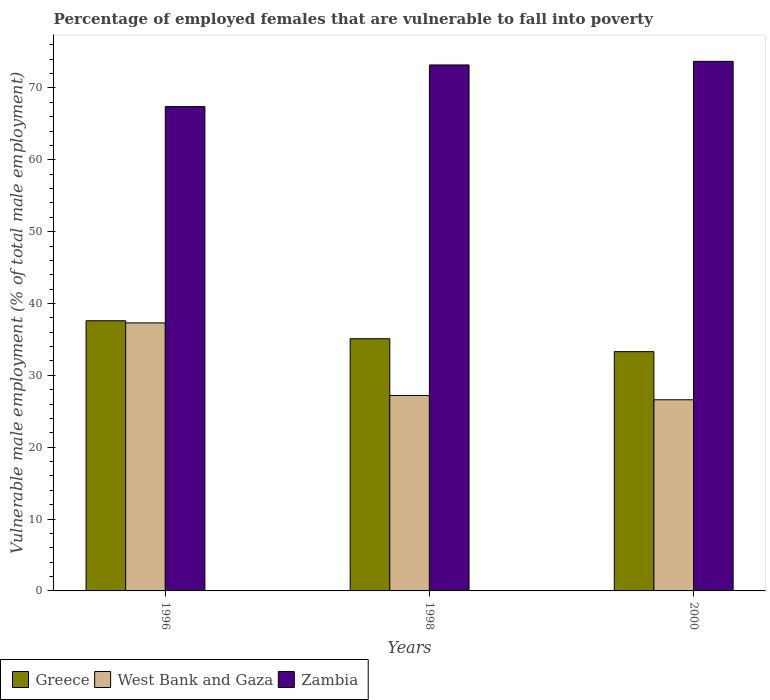How many groups of bars are there?
Your answer should be very brief. 3. Are the number of bars on each tick of the X-axis equal?
Ensure brevity in your answer.  Yes. How many bars are there on the 2nd tick from the right?
Your response must be concise. 3. In how many cases, is the number of bars for a given year not equal to the number of legend labels?
Offer a very short reply. 0. What is the percentage of employed females who are vulnerable to fall into poverty in West Bank and Gaza in 1996?
Keep it short and to the point. 37.3. Across all years, what is the maximum percentage of employed females who are vulnerable to fall into poverty in West Bank and Gaza?
Ensure brevity in your answer.  37.3. Across all years, what is the minimum percentage of employed females who are vulnerable to fall into poverty in Greece?
Offer a very short reply. 33.3. In which year was the percentage of employed females who are vulnerable to fall into poverty in West Bank and Gaza minimum?
Give a very brief answer. 2000. What is the total percentage of employed females who are vulnerable to fall into poverty in Greece in the graph?
Your answer should be compact. 106. What is the difference between the percentage of employed females who are vulnerable to fall into poverty in West Bank and Gaza in 1996 and that in 1998?
Provide a short and direct response. 10.1. What is the difference between the percentage of employed females who are vulnerable to fall into poverty in Zambia in 2000 and the percentage of employed females who are vulnerable to fall into poverty in Greece in 1998?
Provide a succinct answer. 38.6. What is the average percentage of employed females who are vulnerable to fall into poverty in West Bank and Gaza per year?
Offer a very short reply. 30.37. In the year 1996, what is the difference between the percentage of employed females who are vulnerable to fall into poverty in Greece and percentage of employed females who are vulnerable to fall into poverty in West Bank and Gaza?
Keep it short and to the point. 0.3. What is the ratio of the percentage of employed females who are vulnerable to fall into poverty in Zambia in 1998 to that in 2000?
Make the answer very short. 0.99. Is the difference between the percentage of employed females who are vulnerable to fall into poverty in Greece in 1998 and 2000 greater than the difference between the percentage of employed females who are vulnerable to fall into poverty in West Bank and Gaza in 1998 and 2000?
Make the answer very short. Yes. What is the difference between the highest and the second highest percentage of employed females who are vulnerable to fall into poverty in Zambia?
Your answer should be compact. 0.5. What is the difference between the highest and the lowest percentage of employed females who are vulnerable to fall into poverty in Zambia?
Offer a very short reply. 6.3. In how many years, is the percentage of employed females who are vulnerable to fall into poverty in Zambia greater than the average percentage of employed females who are vulnerable to fall into poverty in Zambia taken over all years?
Your answer should be very brief. 2. What does the 1st bar from the left in 2000 represents?
Keep it short and to the point. Greece. What does the 2nd bar from the right in 1996 represents?
Keep it short and to the point. West Bank and Gaza. How many bars are there?
Ensure brevity in your answer.  9. How many years are there in the graph?
Offer a very short reply. 3. What is the difference between two consecutive major ticks on the Y-axis?
Your response must be concise. 10. Does the graph contain grids?
Provide a succinct answer. No. How are the legend labels stacked?
Give a very brief answer. Horizontal. What is the title of the graph?
Your response must be concise. Percentage of employed females that are vulnerable to fall into poverty. What is the label or title of the Y-axis?
Your answer should be very brief. Vulnerable male employment (% of total male employment). What is the Vulnerable male employment (% of total male employment) in Greece in 1996?
Offer a terse response. 37.6. What is the Vulnerable male employment (% of total male employment) of West Bank and Gaza in 1996?
Your answer should be very brief. 37.3. What is the Vulnerable male employment (% of total male employment) of Zambia in 1996?
Your response must be concise. 67.4. What is the Vulnerable male employment (% of total male employment) of Greece in 1998?
Offer a very short reply. 35.1. What is the Vulnerable male employment (% of total male employment) in West Bank and Gaza in 1998?
Your response must be concise. 27.2. What is the Vulnerable male employment (% of total male employment) in Zambia in 1998?
Keep it short and to the point. 73.2. What is the Vulnerable male employment (% of total male employment) in Greece in 2000?
Keep it short and to the point. 33.3. What is the Vulnerable male employment (% of total male employment) in West Bank and Gaza in 2000?
Your answer should be compact. 26.6. What is the Vulnerable male employment (% of total male employment) in Zambia in 2000?
Offer a very short reply. 73.7. Across all years, what is the maximum Vulnerable male employment (% of total male employment) in Greece?
Offer a terse response. 37.6. Across all years, what is the maximum Vulnerable male employment (% of total male employment) in West Bank and Gaza?
Offer a very short reply. 37.3. Across all years, what is the maximum Vulnerable male employment (% of total male employment) of Zambia?
Your answer should be compact. 73.7. Across all years, what is the minimum Vulnerable male employment (% of total male employment) in Greece?
Your response must be concise. 33.3. Across all years, what is the minimum Vulnerable male employment (% of total male employment) in West Bank and Gaza?
Keep it short and to the point. 26.6. Across all years, what is the minimum Vulnerable male employment (% of total male employment) of Zambia?
Ensure brevity in your answer.  67.4. What is the total Vulnerable male employment (% of total male employment) in Greece in the graph?
Make the answer very short. 106. What is the total Vulnerable male employment (% of total male employment) in West Bank and Gaza in the graph?
Your answer should be very brief. 91.1. What is the total Vulnerable male employment (% of total male employment) of Zambia in the graph?
Make the answer very short. 214.3. What is the difference between the Vulnerable male employment (% of total male employment) of West Bank and Gaza in 1996 and that in 1998?
Ensure brevity in your answer.  10.1. What is the difference between the Vulnerable male employment (% of total male employment) of Zambia in 1996 and that in 1998?
Provide a succinct answer. -5.8. What is the difference between the Vulnerable male employment (% of total male employment) in Greece in 1996 and that in 2000?
Make the answer very short. 4.3. What is the difference between the Vulnerable male employment (% of total male employment) of West Bank and Gaza in 1996 and that in 2000?
Give a very brief answer. 10.7. What is the difference between the Vulnerable male employment (% of total male employment) of Greece in 1998 and that in 2000?
Provide a short and direct response. 1.8. What is the difference between the Vulnerable male employment (% of total male employment) of West Bank and Gaza in 1998 and that in 2000?
Your answer should be compact. 0.6. What is the difference between the Vulnerable male employment (% of total male employment) of Greece in 1996 and the Vulnerable male employment (% of total male employment) of Zambia in 1998?
Your answer should be compact. -35.6. What is the difference between the Vulnerable male employment (% of total male employment) of West Bank and Gaza in 1996 and the Vulnerable male employment (% of total male employment) of Zambia in 1998?
Your answer should be very brief. -35.9. What is the difference between the Vulnerable male employment (% of total male employment) in Greece in 1996 and the Vulnerable male employment (% of total male employment) in Zambia in 2000?
Make the answer very short. -36.1. What is the difference between the Vulnerable male employment (% of total male employment) in West Bank and Gaza in 1996 and the Vulnerable male employment (% of total male employment) in Zambia in 2000?
Make the answer very short. -36.4. What is the difference between the Vulnerable male employment (% of total male employment) of Greece in 1998 and the Vulnerable male employment (% of total male employment) of Zambia in 2000?
Offer a terse response. -38.6. What is the difference between the Vulnerable male employment (% of total male employment) in West Bank and Gaza in 1998 and the Vulnerable male employment (% of total male employment) in Zambia in 2000?
Ensure brevity in your answer.  -46.5. What is the average Vulnerable male employment (% of total male employment) in Greece per year?
Make the answer very short. 35.33. What is the average Vulnerable male employment (% of total male employment) in West Bank and Gaza per year?
Provide a succinct answer. 30.37. What is the average Vulnerable male employment (% of total male employment) in Zambia per year?
Your answer should be very brief. 71.43. In the year 1996, what is the difference between the Vulnerable male employment (% of total male employment) of Greece and Vulnerable male employment (% of total male employment) of West Bank and Gaza?
Offer a very short reply. 0.3. In the year 1996, what is the difference between the Vulnerable male employment (% of total male employment) in Greece and Vulnerable male employment (% of total male employment) in Zambia?
Provide a succinct answer. -29.8. In the year 1996, what is the difference between the Vulnerable male employment (% of total male employment) in West Bank and Gaza and Vulnerable male employment (% of total male employment) in Zambia?
Ensure brevity in your answer.  -30.1. In the year 1998, what is the difference between the Vulnerable male employment (% of total male employment) of Greece and Vulnerable male employment (% of total male employment) of Zambia?
Your answer should be very brief. -38.1. In the year 1998, what is the difference between the Vulnerable male employment (% of total male employment) of West Bank and Gaza and Vulnerable male employment (% of total male employment) of Zambia?
Ensure brevity in your answer.  -46. In the year 2000, what is the difference between the Vulnerable male employment (% of total male employment) of Greece and Vulnerable male employment (% of total male employment) of West Bank and Gaza?
Provide a succinct answer. 6.7. In the year 2000, what is the difference between the Vulnerable male employment (% of total male employment) in Greece and Vulnerable male employment (% of total male employment) in Zambia?
Offer a terse response. -40.4. In the year 2000, what is the difference between the Vulnerable male employment (% of total male employment) in West Bank and Gaza and Vulnerable male employment (% of total male employment) in Zambia?
Give a very brief answer. -47.1. What is the ratio of the Vulnerable male employment (% of total male employment) of Greece in 1996 to that in 1998?
Provide a succinct answer. 1.07. What is the ratio of the Vulnerable male employment (% of total male employment) of West Bank and Gaza in 1996 to that in 1998?
Ensure brevity in your answer.  1.37. What is the ratio of the Vulnerable male employment (% of total male employment) of Zambia in 1996 to that in 1998?
Make the answer very short. 0.92. What is the ratio of the Vulnerable male employment (% of total male employment) in Greece in 1996 to that in 2000?
Your response must be concise. 1.13. What is the ratio of the Vulnerable male employment (% of total male employment) of West Bank and Gaza in 1996 to that in 2000?
Make the answer very short. 1.4. What is the ratio of the Vulnerable male employment (% of total male employment) of Zambia in 1996 to that in 2000?
Provide a succinct answer. 0.91. What is the ratio of the Vulnerable male employment (% of total male employment) of Greece in 1998 to that in 2000?
Provide a short and direct response. 1.05. What is the ratio of the Vulnerable male employment (% of total male employment) of West Bank and Gaza in 1998 to that in 2000?
Offer a terse response. 1.02. What is the ratio of the Vulnerable male employment (% of total male employment) in Zambia in 1998 to that in 2000?
Your response must be concise. 0.99. What is the difference between the highest and the second highest Vulnerable male employment (% of total male employment) in Greece?
Your answer should be very brief. 2.5. 